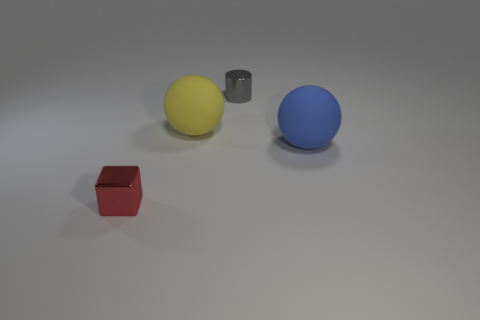Add 1 large blue metallic objects. How many objects exist? 5 Subtract all blocks. How many objects are left? 3 Subtract all tiny yellow rubber cubes. Subtract all metallic things. How many objects are left? 2 Add 2 yellow rubber balls. How many yellow rubber balls are left? 3 Add 3 blue matte things. How many blue matte things exist? 4 Subtract 0 blue cylinders. How many objects are left? 4 